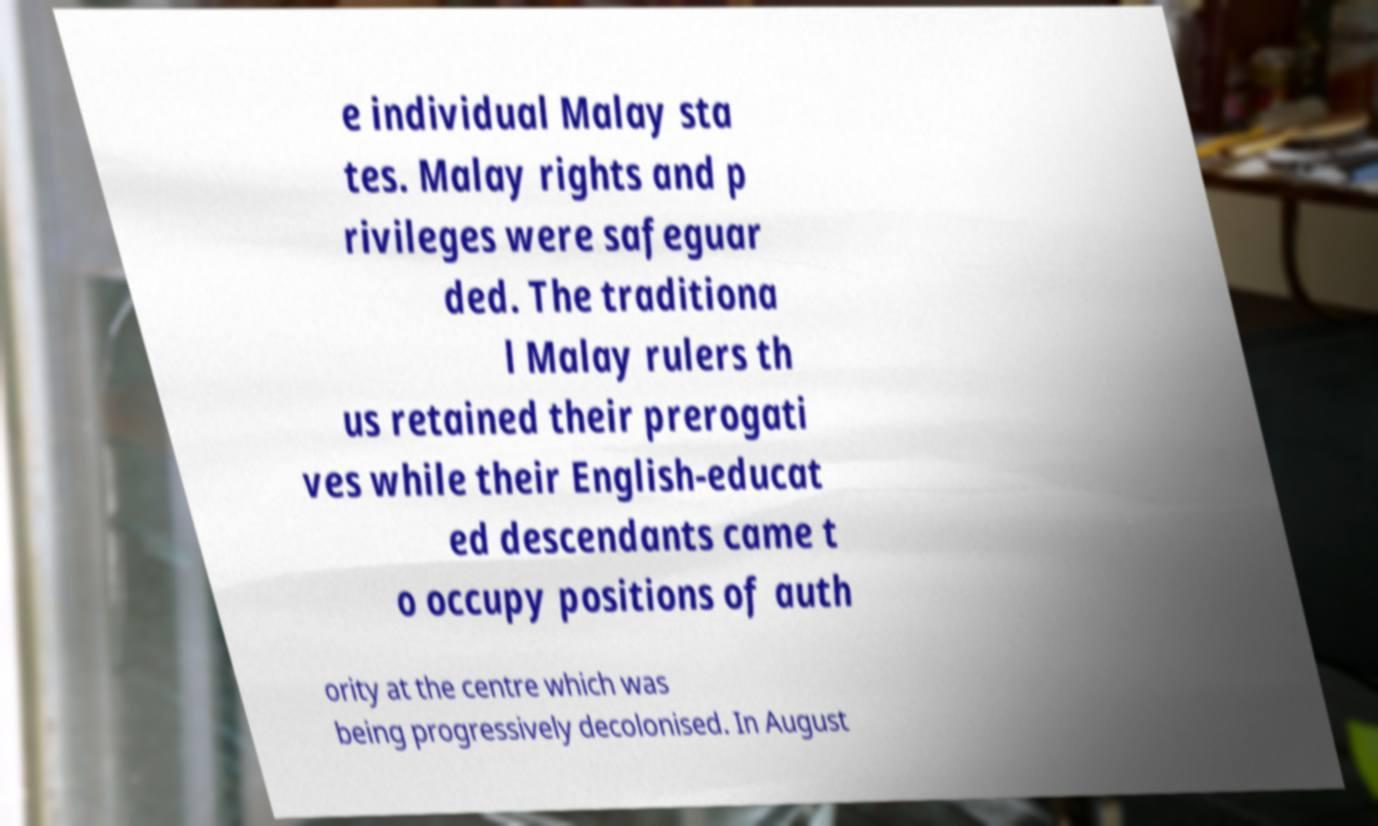Could you extract and type out the text from this image? e individual Malay sta tes. Malay rights and p rivileges were safeguar ded. The traditiona l Malay rulers th us retained their prerogati ves while their English-educat ed descendants came t o occupy positions of auth ority at the centre which was being progressively decolonised. In August 